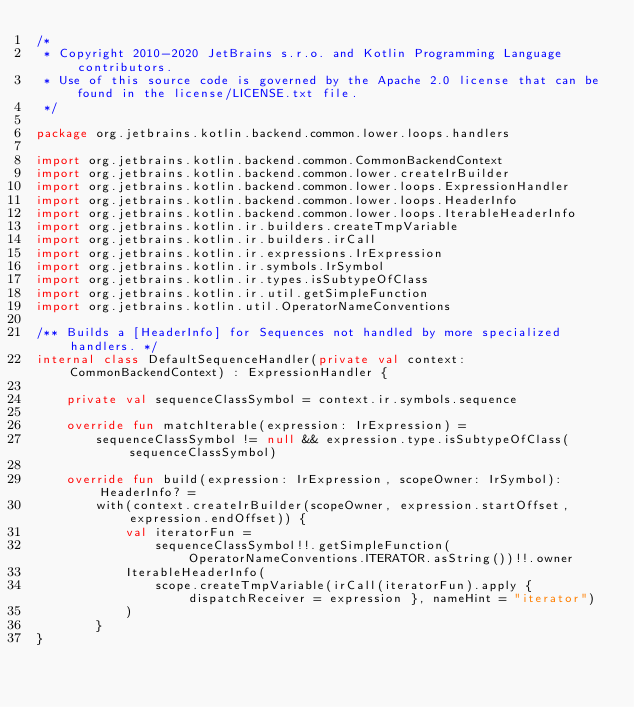<code> <loc_0><loc_0><loc_500><loc_500><_Kotlin_>/*
 * Copyright 2010-2020 JetBrains s.r.o. and Kotlin Programming Language contributors.
 * Use of this source code is governed by the Apache 2.0 license that can be found in the license/LICENSE.txt file.
 */

package org.jetbrains.kotlin.backend.common.lower.loops.handlers

import org.jetbrains.kotlin.backend.common.CommonBackendContext
import org.jetbrains.kotlin.backend.common.lower.createIrBuilder
import org.jetbrains.kotlin.backend.common.lower.loops.ExpressionHandler
import org.jetbrains.kotlin.backend.common.lower.loops.HeaderInfo
import org.jetbrains.kotlin.backend.common.lower.loops.IterableHeaderInfo
import org.jetbrains.kotlin.ir.builders.createTmpVariable
import org.jetbrains.kotlin.ir.builders.irCall
import org.jetbrains.kotlin.ir.expressions.IrExpression
import org.jetbrains.kotlin.ir.symbols.IrSymbol
import org.jetbrains.kotlin.ir.types.isSubtypeOfClass
import org.jetbrains.kotlin.ir.util.getSimpleFunction
import org.jetbrains.kotlin.util.OperatorNameConventions

/** Builds a [HeaderInfo] for Sequences not handled by more specialized handlers. */
internal class DefaultSequenceHandler(private val context: CommonBackendContext) : ExpressionHandler {

    private val sequenceClassSymbol = context.ir.symbols.sequence

    override fun matchIterable(expression: IrExpression) =
        sequenceClassSymbol != null && expression.type.isSubtypeOfClass(sequenceClassSymbol)

    override fun build(expression: IrExpression, scopeOwner: IrSymbol): HeaderInfo? =
        with(context.createIrBuilder(scopeOwner, expression.startOffset, expression.endOffset)) {
            val iteratorFun =
                sequenceClassSymbol!!.getSimpleFunction(OperatorNameConventions.ITERATOR.asString())!!.owner
            IterableHeaderInfo(
                scope.createTmpVariable(irCall(iteratorFun).apply { dispatchReceiver = expression }, nameHint = "iterator")
            )
        }
}</code> 